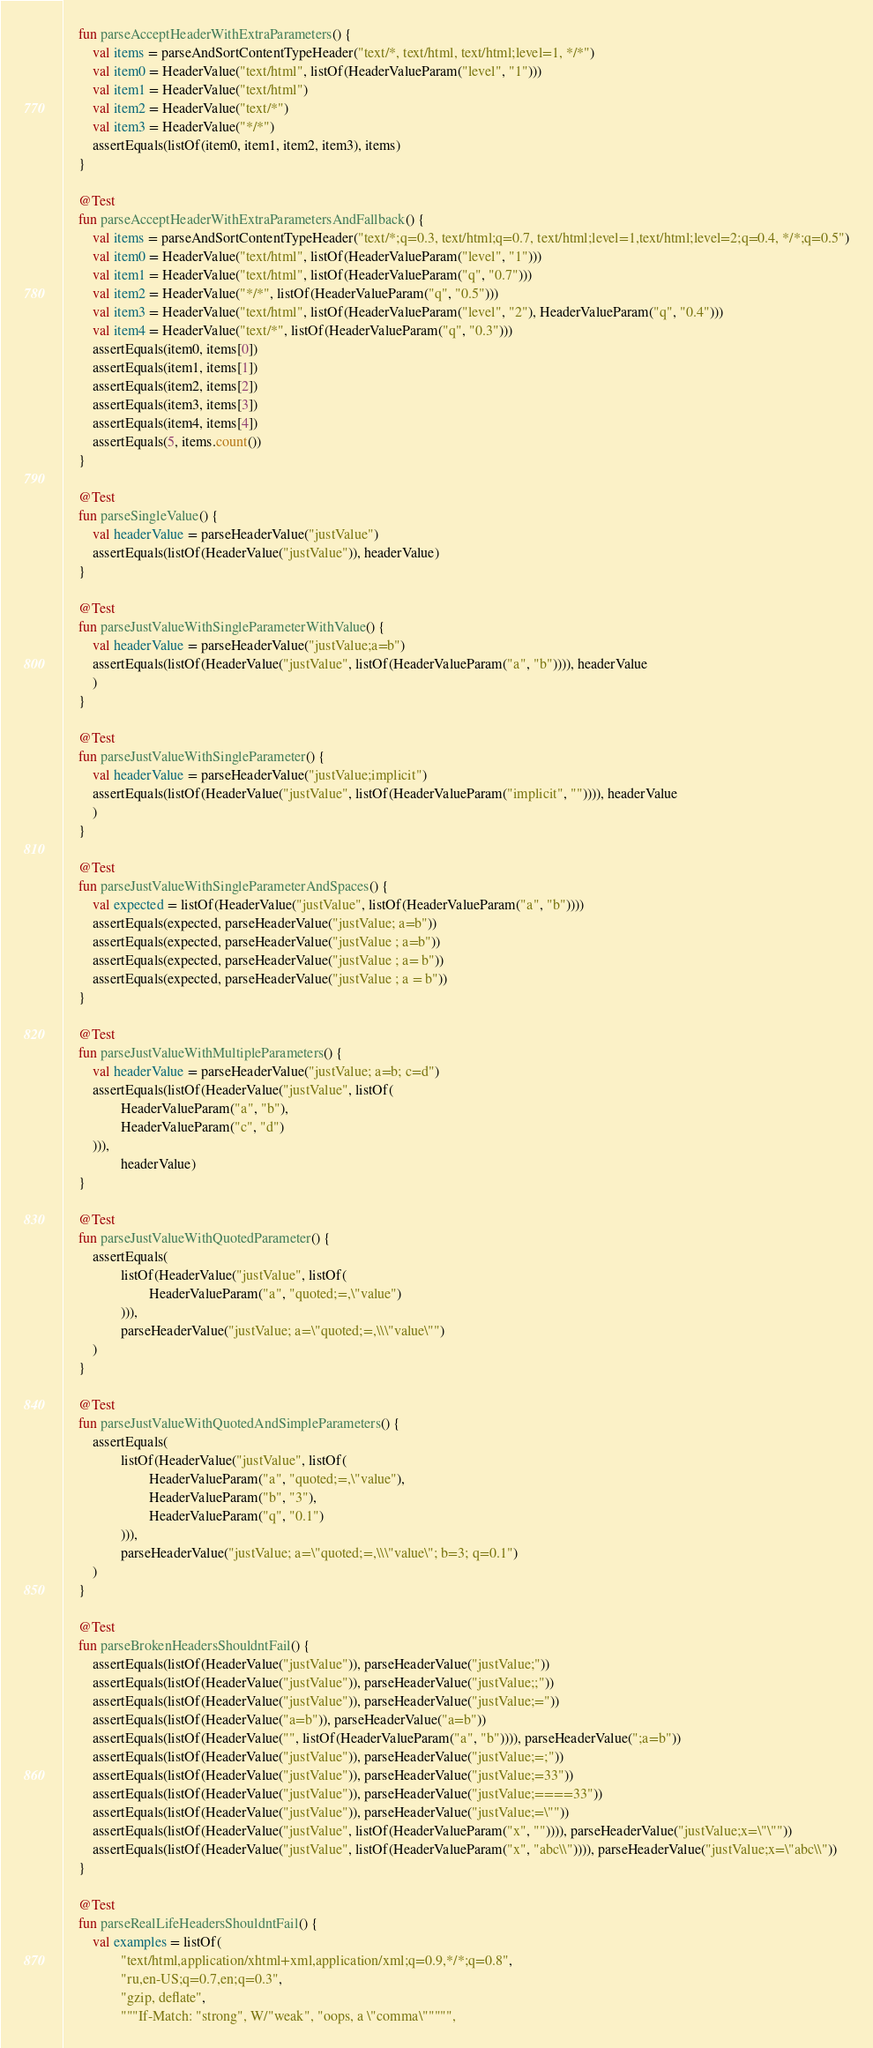<code> <loc_0><loc_0><loc_500><loc_500><_Kotlin_>    fun parseAcceptHeaderWithExtraParameters() {
        val items = parseAndSortContentTypeHeader("text/*, text/html, text/html;level=1, */*")
        val item0 = HeaderValue("text/html", listOf(HeaderValueParam("level", "1")))
        val item1 = HeaderValue("text/html")
        val item2 = HeaderValue("text/*")
        val item3 = HeaderValue("*/*")
        assertEquals(listOf(item0, item1, item2, item3), items)
    }

    @Test
    fun parseAcceptHeaderWithExtraParametersAndFallback() {
        val items = parseAndSortContentTypeHeader("text/*;q=0.3, text/html;q=0.7, text/html;level=1,text/html;level=2;q=0.4, */*;q=0.5")
        val item0 = HeaderValue("text/html", listOf(HeaderValueParam("level", "1")))
        val item1 = HeaderValue("text/html", listOf(HeaderValueParam("q", "0.7")))
        val item2 = HeaderValue("*/*", listOf(HeaderValueParam("q", "0.5")))
        val item3 = HeaderValue("text/html", listOf(HeaderValueParam("level", "2"), HeaderValueParam("q", "0.4")))
        val item4 = HeaderValue("text/*", listOf(HeaderValueParam("q", "0.3")))
        assertEquals(item0, items[0])
        assertEquals(item1, items[1])
        assertEquals(item2, items[2])
        assertEquals(item3, items[3])
        assertEquals(item4, items[4])
        assertEquals(5, items.count())
    }

    @Test
    fun parseSingleValue() {
        val headerValue = parseHeaderValue("justValue")
        assertEquals(listOf(HeaderValue("justValue")), headerValue)
    }

    @Test
    fun parseJustValueWithSingleParameterWithValue() {
        val headerValue = parseHeaderValue("justValue;a=b")
        assertEquals(listOf(HeaderValue("justValue", listOf(HeaderValueParam("a", "b")))), headerValue
        )
    }

    @Test
    fun parseJustValueWithSingleParameter() {
        val headerValue = parseHeaderValue("justValue;implicit")
        assertEquals(listOf(HeaderValue("justValue", listOf(HeaderValueParam("implicit", "")))), headerValue
        )
    }

    @Test
    fun parseJustValueWithSingleParameterAndSpaces() {
        val expected = listOf(HeaderValue("justValue", listOf(HeaderValueParam("a", "b"))))
        assertEquals(expected, parseHeaderValue("justValue; a=b"))
        assertEquals(expected, parseHeaderValue("justValue ; a=b"))
        assertEquals(expected, parseHeaderValue("justValue ; a= b"))
        assertEquals(expected, parseHeaderValue("justValue ; a = b"))
    }

    @Test
    fun parseJustValueWithMultipleParameters() {
        val headerValue = parseHeaderValue("justValue; a=b; c=d")
        assertEquals(listOf(HeaderValue("justValue", listOf(
                HeaderValueParam("a", "b"),
                HeaderValueParam("c", "d")
        ))),
                headerValue)
    }

    @Test
    fun parseJustValueWithQuotedParameter() {
        assertEquals(
                listOf(HeaderValue("justValue", listOf(
                        HeaderValueParam("a", "quoted;=,\"value")
                ))),
                parseHeaderValue("justValue; a=\"quoted;=,\\\"value\"")
        )
    }

    @Test
    fun parseJustValueWithQuotedAndSimpleParameters() {
        assertEquals(
                listOf(HeaderValue("justValue", listOf(
                        HeaderValueParam("a", "quoted;=,\"value"),
                        HeaderValueParam("b", "3"),
                        HeaderValueParam("q", "0.1")
                ))),
                parseHeaderValue("justValue; a=\"quoted;=,\\\"value\"; b=3; q=0.1")
        )
    }

    @Test
    fun parseBrokenHeadersShouldntFail() {
        assertEquals(listOf(HeaderValue("justValue")), parseHeaderValue("justValue;"))
        assertEquals(listOf(HeaderValue("justValue")), parseHeaderValue("justValue;;"))
        assertEquals(listOf(HeaderValue("justValue")), parseHeaderValue("justValue;="))
        assertEquals(listOf(HeaderValue("a=b")), parseHeaderValue("a=b"))
        assertEquals(listOf(HeaderValue("", listOf(HeaderValueParam("a", "b")))), parseHeaderValue(";a=b"))
        assertEquals(listOf(HeaderValue("justValue")), parseHeaderValue("justValue;=;"))
        assertEquals(listOf(HeaderValue("justValue")), parseHeaderValue("justValue;=33"))
        assertEquals(listOf(HeaderValue("justValue")), parseHeaderValue("justValue;====33"))
        assertEquals(listOf(HeaderValue("justValue")), parseHeaderValue("justValue;=\""))
        assertEquals(listOf(HeaderValue("justValue", listOf(HeaderValueParam("x", "")))), parseHeaderValue("justValue;x=\"\""))
        assertEquals(listOf(HeaderValue("justValue", listOf(HeaderValueParam("x", "abc\\")))), parseHeaderValue("justValue;x=\"abc\\"))
    }

    @Test
    fun parseRealLifeHeadersShouldntFail() {
        val examples = listOf(
                "text/html,application/xhtml+xml,application/xml;q=0.9,*/*;q=0.8",
                "ru,en-US;q=0.7,en;q=0.3",
                "gzip, deflate",
                """If-Match: "strong", W/"weak", "oops, a \"comma\""""",</code> 